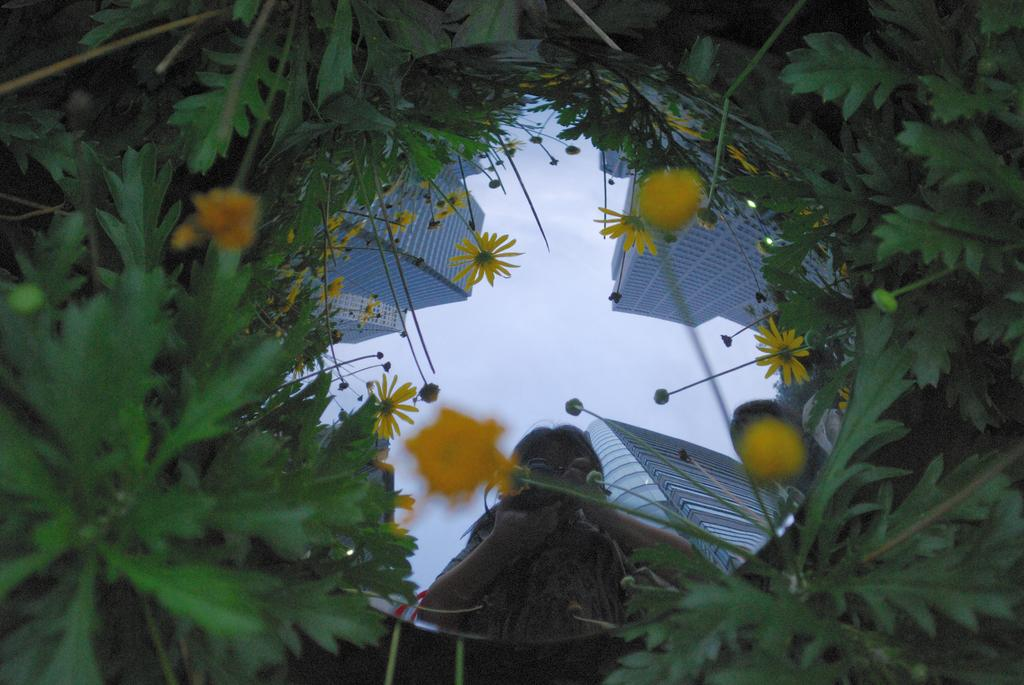What type of living organisms can be seen in the image? Plants and flowers are visible in the image. What object in the image reflects its surroundings? There is a mirror in the image that reflects a person, buildings, flowers, and the sky. Can you describe the mirror's reflection of the sky? The mirror reflects the sky, which is visible in the image. How many quinces are visible in the image? There are no quinces present in the image. Can you describe the person's step in the image? There is no person taking a step in the image; the mirror reflects a person, but their actions are not visible. 